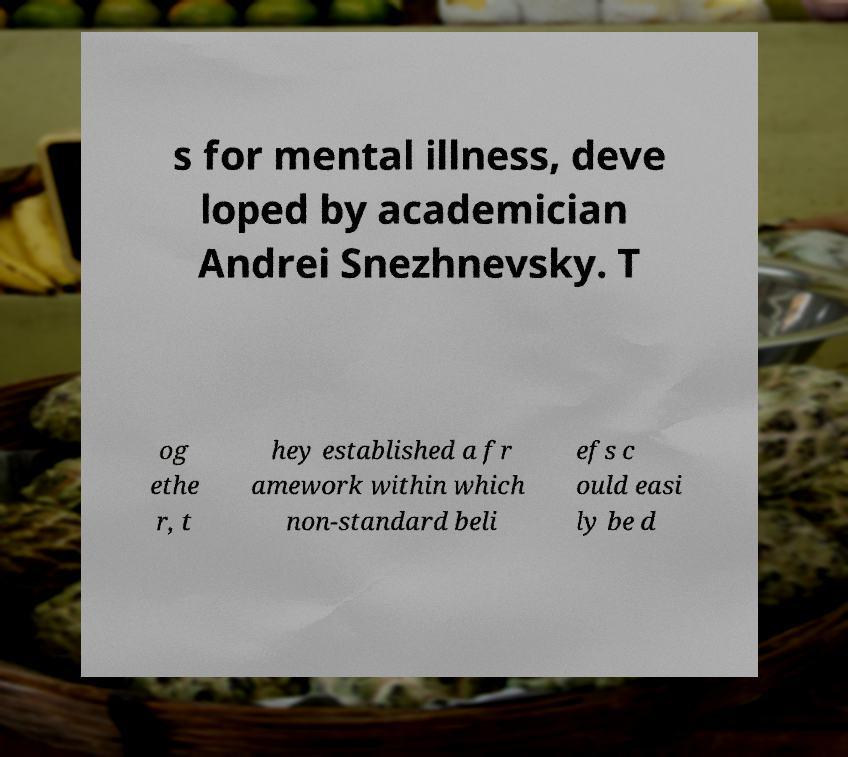For documentation purposes, I need the text within this image transcribed. Could you provide that? s for mental illness, deve loped by academician Andrei Snezhnevsky. T og ethe r, t hey established a fr amework within which non-standard beli efs c ould easi ly be d 